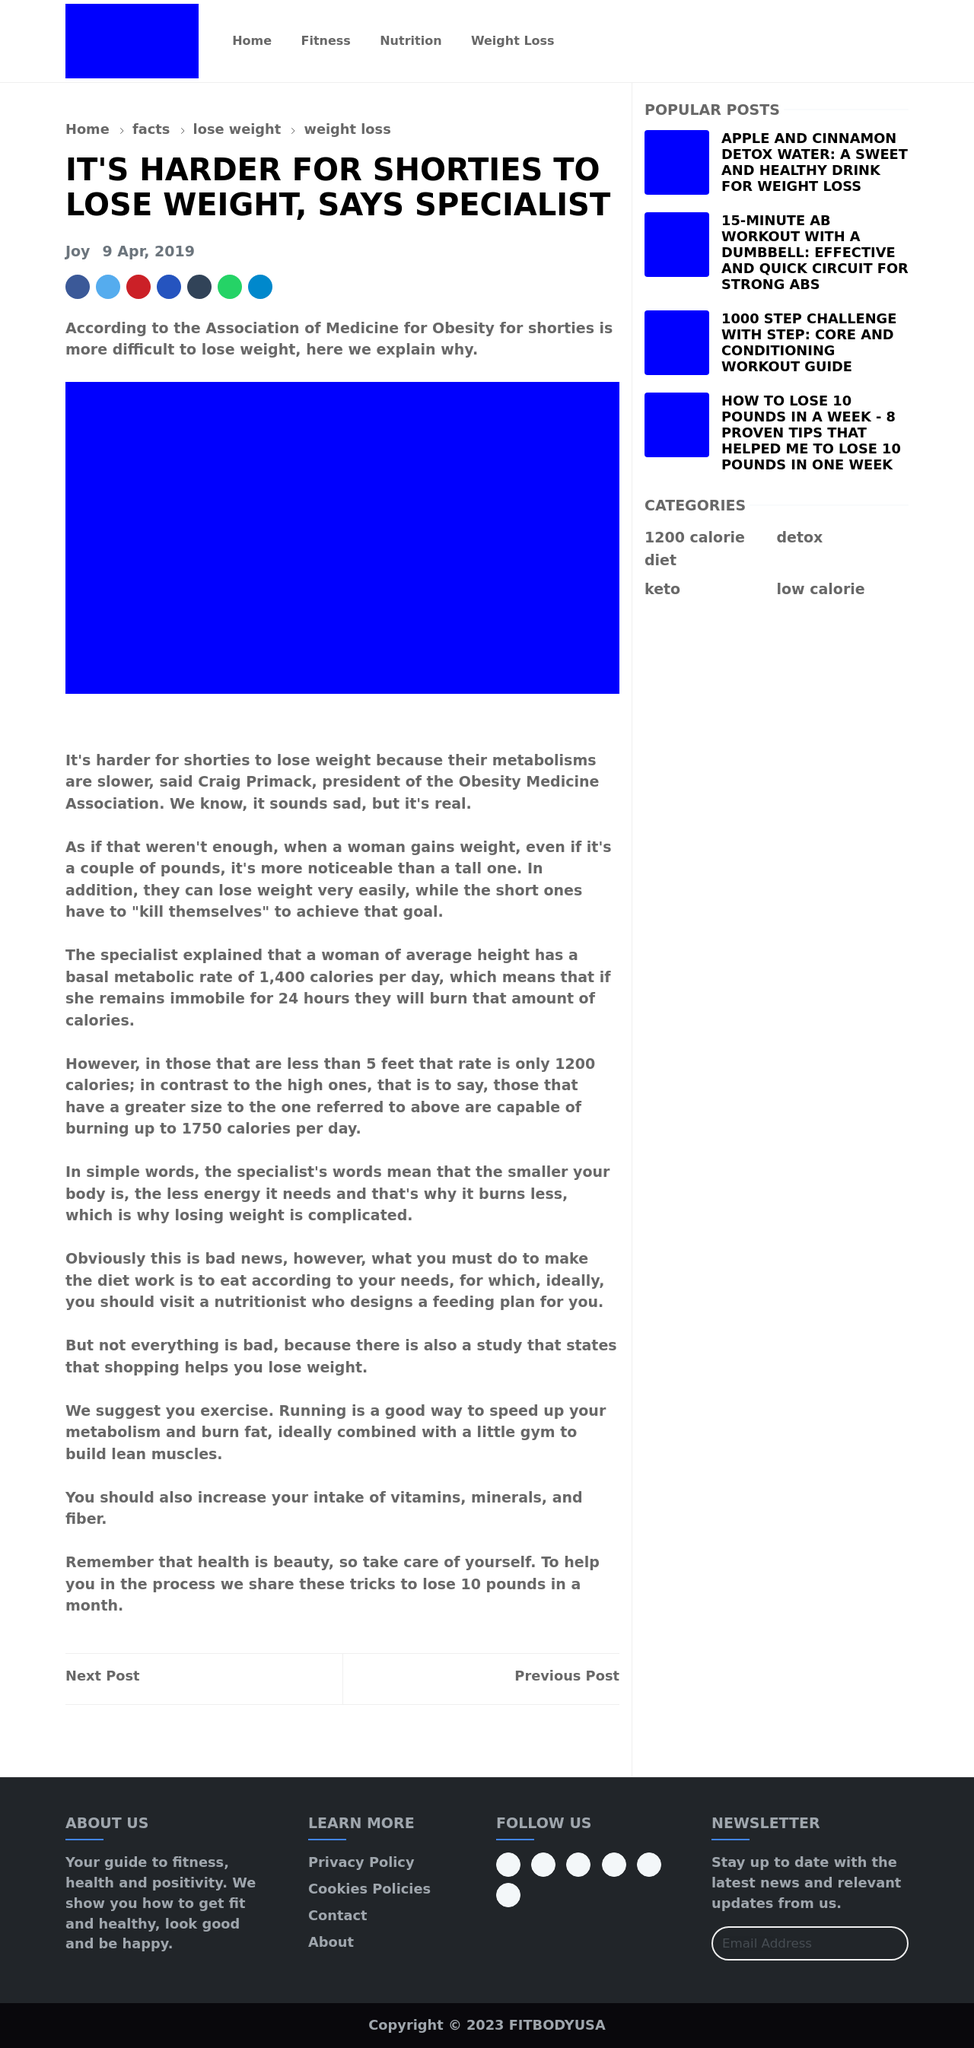Considering the website's focus on health and fitness, what type of additional content could be beneficial to include? For a website focused on health and fitness, incorporating interactive elements like fitness trackers, dietary calculators, or personalized workout plans could significantly enhance user engagement. Adding a blog section where users can read and share experiences, tips, or success stories can also be beneficial. Including expert advice columns, video tutorials for exercises, and nutritional guides would provide comprehensive support for someone looking to improve their health and fitness.  What technologies besides HTML could be utilized to enrich the site's functionality? Beyond HTML, using CSS for styling and JavaScript for interactive elements is essential. You might consider incorporating frameworks like Bootstrap for responsive design, and libraries like React or Vue.js for a dynamic and efficient user interface. For backend operations like storing user data or handling dynamic content updates, technologies like PHP, Node.js, or Python with frameworks like Django should be considered. Database solutions like MySQL or MongoDB could also be employed to manage user data effectively. 